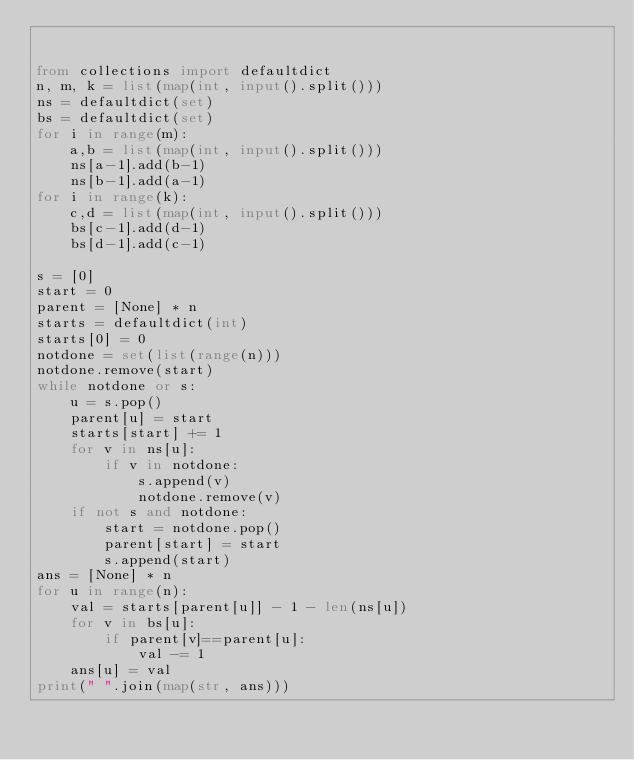<code> <loc_0><loc_0><loc_500><loc_500><_Python_>

from collections import defaultdict
n, m, k = list(map(int, input().split()))
ns = defaultdict(set)
bs = defaultdict(set)
for i in range(m):
    a,b = list(map(int, input().split()))
    ns[a-1].add(b-1)
    ns[b-1].add(a-1)
for i in range(k):
    c,d = list(map(int, input().split()))
    bs[c-1].add(d-1)
    bs[d-1].add(c-1)
    
s = [0]
start = 0
parent = [None] * n
starts = defaultdict(int)
starts[0] = 0
notdone = set(list(range(n)))
notdone.remove(start)
while notdone or s:
    u = s.pop()
    parent[u] = start
    starts[start] += 1
    for v in ns[u]:
        if v in notdone:
            s.append(v)
            notdone.remove(v)
    if not s and notdone:
        start = notdone.pop()
        parent[start] = start
        s.append(start)
ans = [None] * n
for u in range(n):
    val = starts[parent[u]] - 1 - len(ns[u])
    for v in bs[u]:
        if parent[v]==parent[u]:
            val -= 1
    ans[u] = val
print(" ".join(map(str, ans)))</code> 